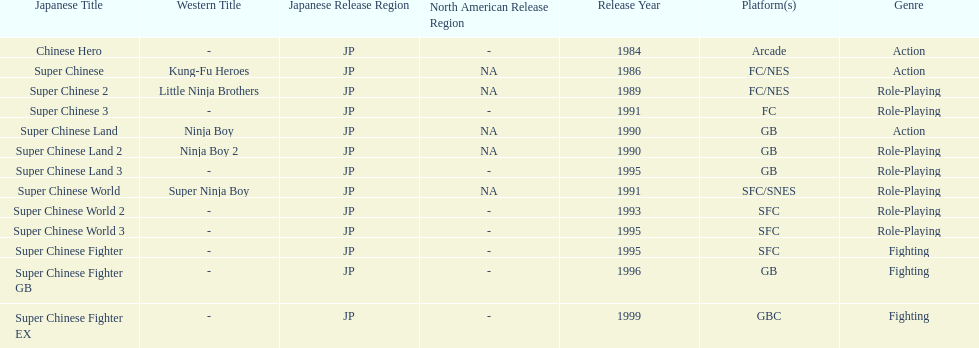Of the titles released in north america, which had the least releases? Super Chinese World. Parse the full table. {'header': ['Japanese Title', 'Western Title', 'Japanese Release Region', 'North American Release Region', 'Release Year', 'Platform(s)', 'Genre'], 'rows': [['Chinese Hero', '-', 'JP', '-', '1984', 'Arcade', 'Action'], ['Super Chinese', 'Kung-Fu Heroes', 'JP', 'NA', '1986', 'FC/NES', 'Action'], ['Super Chinese 2', 'Little Ninja Brothers', 'JP', 'NA', '1989', 'FC/NES', 'Role-Playing'], ['Super Chinese 3', '-', 'JP', '-', '1991', 'FC', 'Role-Playing'], ['Super Chinese Land', 'Ninja Boy', 'JP', 'NA', '1990', 'GB', 'Action'], ['Super Chinese Land 2', 'Ninja Boy 2', 'JP', 'NA', '1990', 'GB', 'Role-Playing'], ['Super Chinese Land 3', '-', 'JP', '-', '1995', 'GB', 'Role-Playing'], ['Super Chinese World', 'Super Ninja Boy', 'JP', 'NA', '1991', 'SFC/SNES', 'Role-Playing'], ['Super Chinese World 2', '-', 'JP', '-', '1993', 'SFC', 'Role-Playing'], ['Super Chinese World 3', '-', 'JP', '-', '1995', 'SFC', 'Role-Playing'], ['Super Chinese Fighter', '-', 'JP', '-', '1995', 'SFC', 'Fighting'], ['Super Chinese Fighter GB', '-', 'JP', '-', '1996', 'GB', 'Fighting'], ['Super Chinese Fighter EX', '-', 'JP', '-', '1999', 'GBC', 'Fighting']]} 